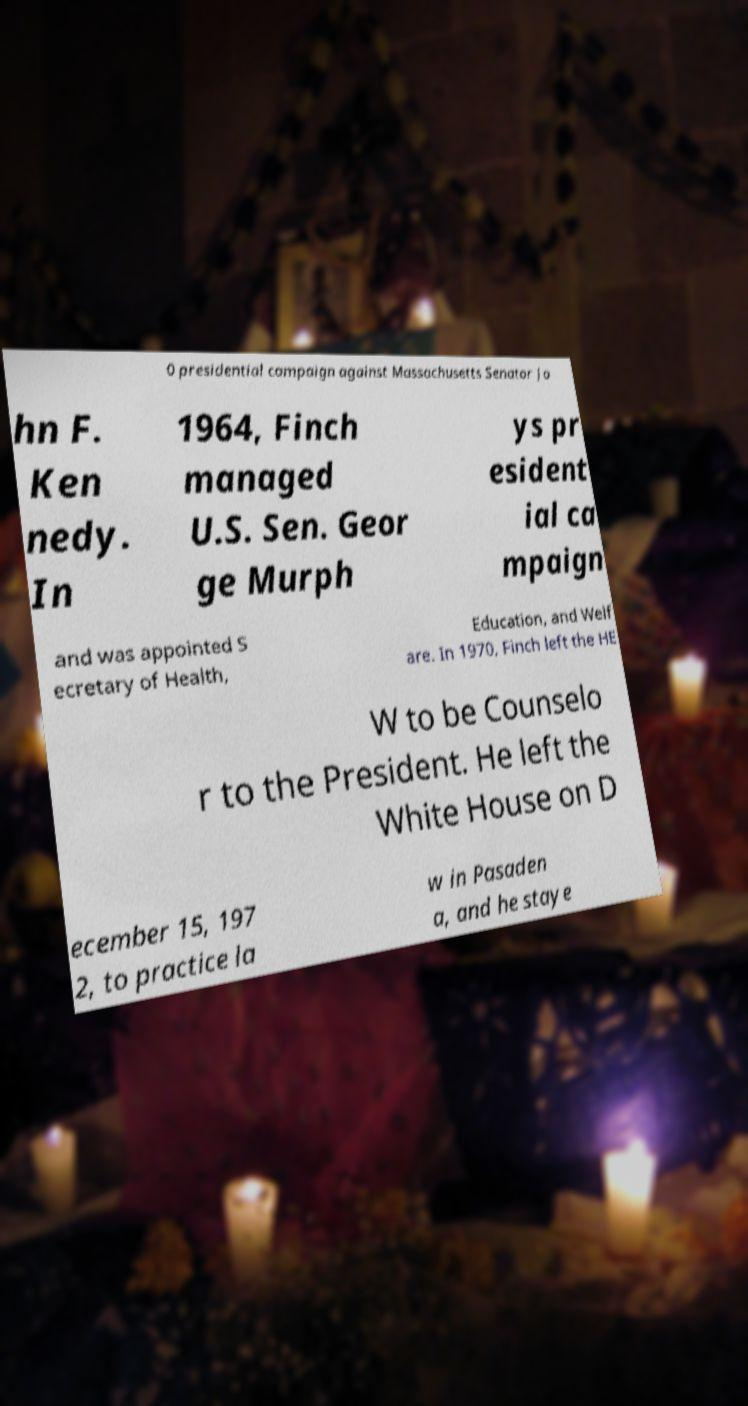Please identify and transcribe the text found in this image. 0 presidential campaign against Massachusetts Senator Jo hn F. Ken nedy. In 1964, Finch managed U.S. Sen. Geor ge Murph ys pr esident ial ca mpaign and was appointed S ecretary of Health, Education, and Welf are. In 1970, Finch left the HE W to be Counselo r to the President. He left the White House on D ecember 15, 197 2, to practice la w in Pasaden a, and he staye 